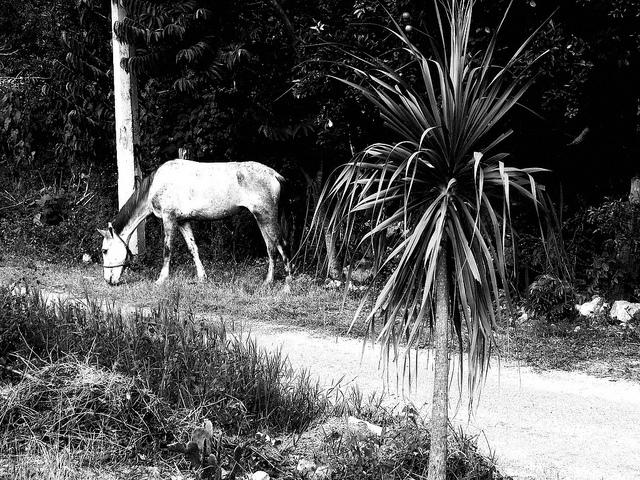What animal is that?
Be succinct. Horse. Is this horse wild?
Answer briefly. No. Is the road paved?
Write a very short answer. No. 